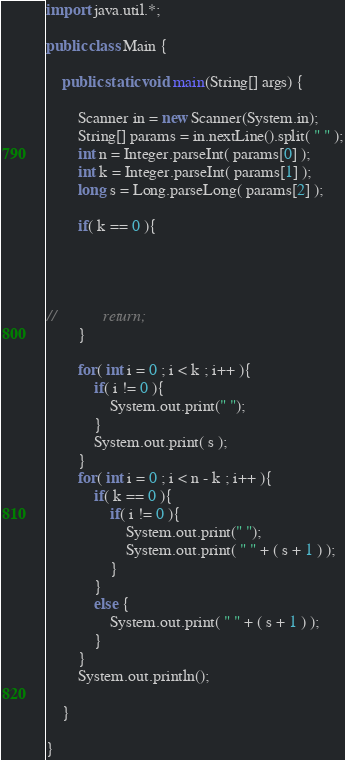Convert code to text. <code><loc_0><loc_0><loc_500><loc_500><_Java_>import java.util.*;

public class Main {

    public static void main(String[] args) {

        Scanner in = new Scanner(System.in);
        String[] params = in.nextLine().split( " " );
        int n = Integer.parseInt( params[0] );
        int k = Integer.parseInt( params[1] );
        long s = Long.parseLong( params[2] );

        if( k == 0 ){




//            return;
        }

        for( int i = 0 ; i < k ; i++ ){
            if( i != 0 ){
                System.out.print(" ");
            }
            System.out.print( s );
        }
        for( int i = 0 ; i < n - k ; i++ ){
            if( k == 0 ){
                if( i != 0 ){
                    System.out.print(" ");
                    System.out.print( " " + ( s + 1 ) );
                }
            }
            else {
                System.out.print( " " + ( s + 1 ) );
            }
        }
        System.out.println();

    }

}
</code> 